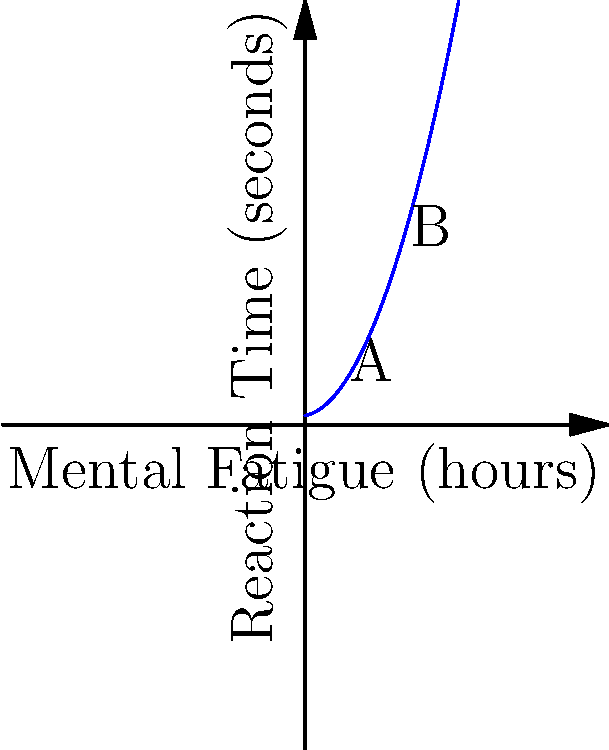In the graph depicting the relationship between reaction time and mental fatigue in athletes, what is the approximate increase in reaction time (in seconds) as mental fatigue increases from point A to point B? To solve this problem, we need to follow these steps:

1. Identify the coordinates of points A and B:
   Point A: (1, f(1))
   Point B: (3, f(3))

2. Calculate the reaction time at point A:
   f(1) = 0.5(1)^2 + 0.2(1) + 0.3 = 0.5 + 0.2 + 0.3 = 1.0 seconds

3. Calculate the reaction time at point B:
   f(3) = 0.5(3)^2 + 0.2(3) + 0.3 = 4.5 + 0.6 + 0.3 = 5.4 seconds

4. Calculate the difference in reaction time:
   Increase = Reaction time at B - Reaction time at A
   Increase = 5.4 - 1.0 = 4.4 seconds

Therefore, the approximate increase in reaction time from point A to point B is 4.4 seconds.
Answer: 4.4 seconds 